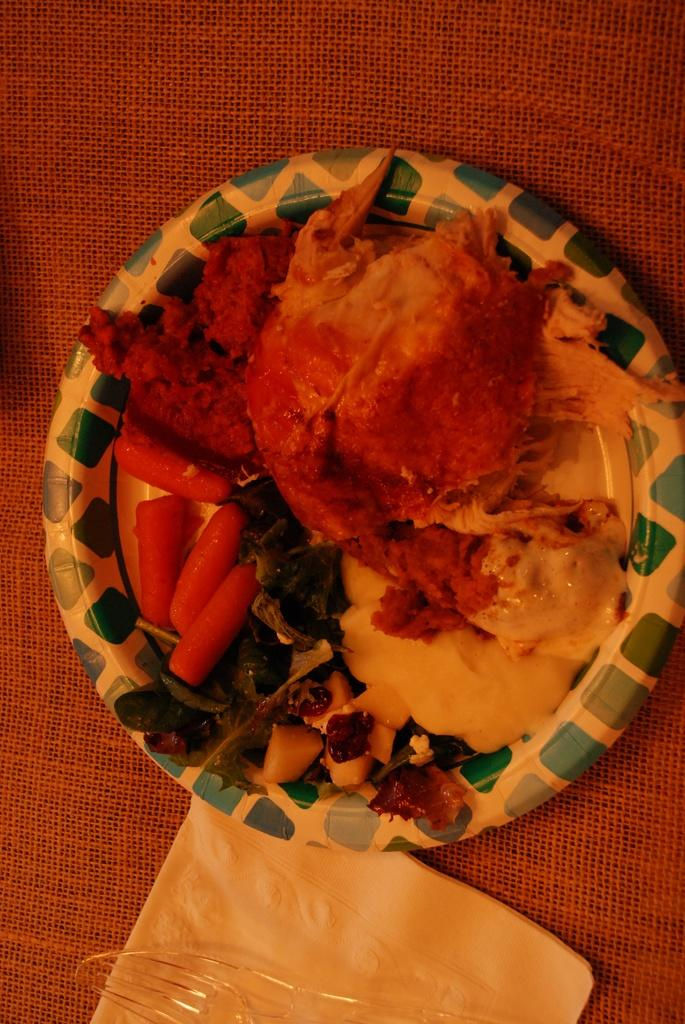What is on the plate in the image? There is food on a plate in the image. What is used for wiping or cleaning in the image? There is a paper napkin in the image. What utensils are present in the image? There is a spoon and a fork in the image. How does the zephyr affect the food on the plate in the image? There is no mention of a zephyr or any wind in the image, so it cannot be determined how it would affect the food on the plate. 